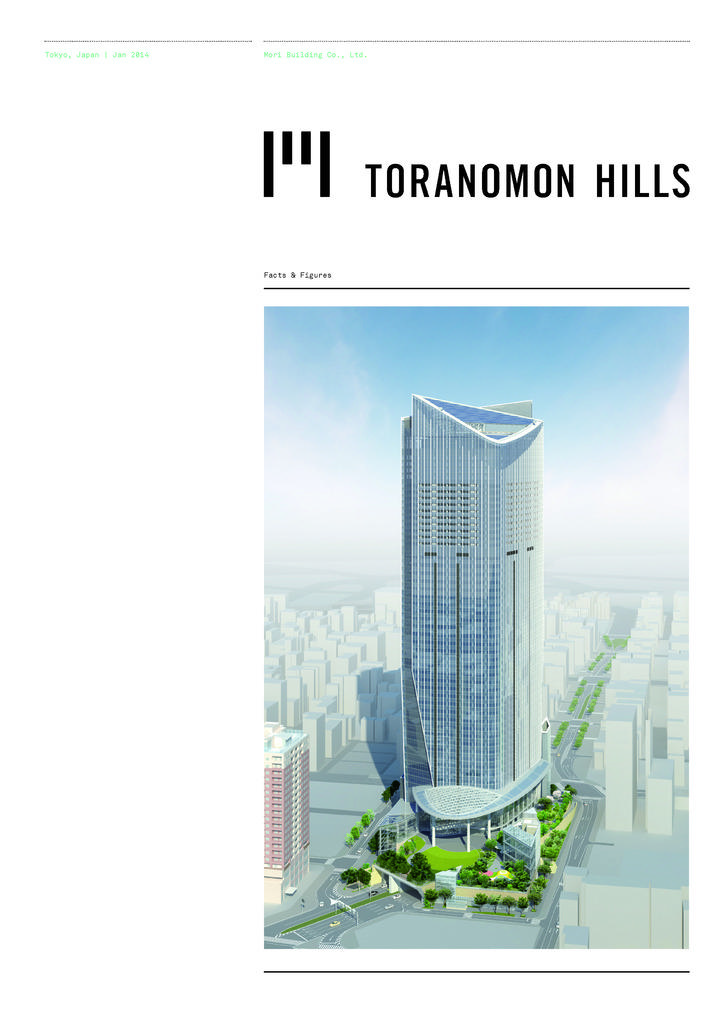What type of visual representation is shown in the image? The image is a poster. What structures are depicted on the poster? There are buildings depicted on the poster. What type of natural elements are shown on the poster? There are trees depicted on the poster. What part of the environment is visible on the poster? The sky is visible on the poster. What additional information is provided on the poster? There is text present on the poster. What invention is being showcased on the sidewalk in the image? There is no sidewalk or invention present in the image; it is a poster featuring buildings, trees, the sky, and text. 